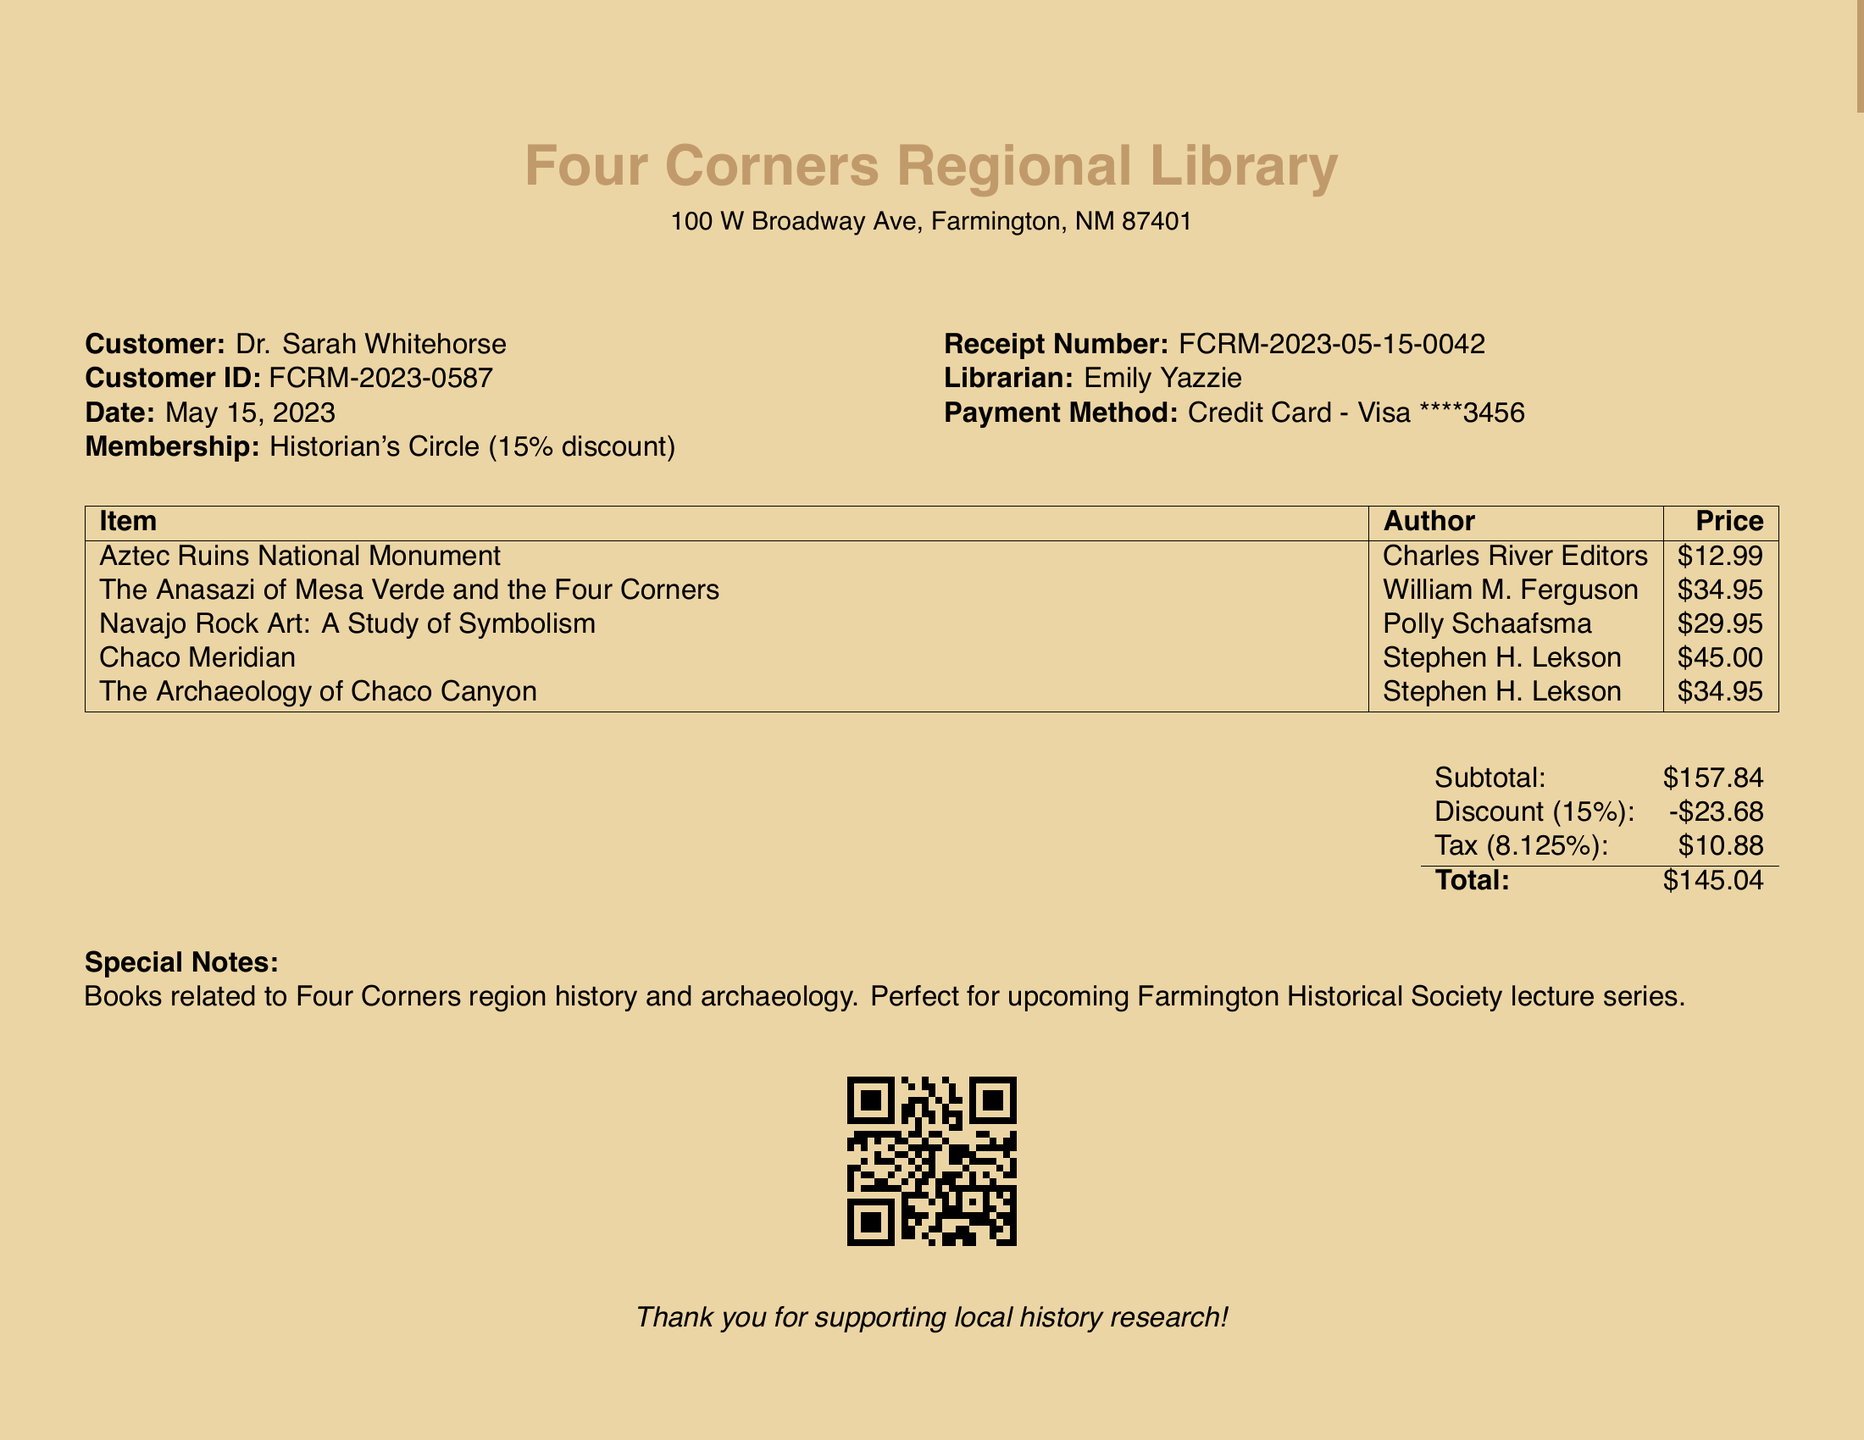What is the customer's name? The customer's name is explicitly mentioned in the document.
Answer: Dr. Sarah Whitehorse What is the total amount after discount and tax? The total amount calculated after applying the discount and tax is displayed in the summary.
Answer: $145.04 What date was the transaction made? The date of the transaction is listed near the beginning of the document.
Answer: May 15, 2023 What is the membership type? The document states the type of membership the customer holds.
Answer: Historian's Circle How much was the discount applied? The discount amount after applying the membership discount is specified in the totals section.
Answer: $23.68 Who was the librarian assisting with this transaction? The name of the librarian who handled the transaction is provided in the document.
Answer: Emily Yazzie What is the receipt number? The unique identifier for this transaction is listed clearly in the receipt.
Answer: FCRM-2023-05-15-0042 What genre do the purchased books relate to? The special notes section identifies the focus of the books purchased.
Answer: Four Corners region history and archaeology How many items were purchased in total? By counting the items listed in the itemized section, we can determine the total number of purchases.
Answer: 5 